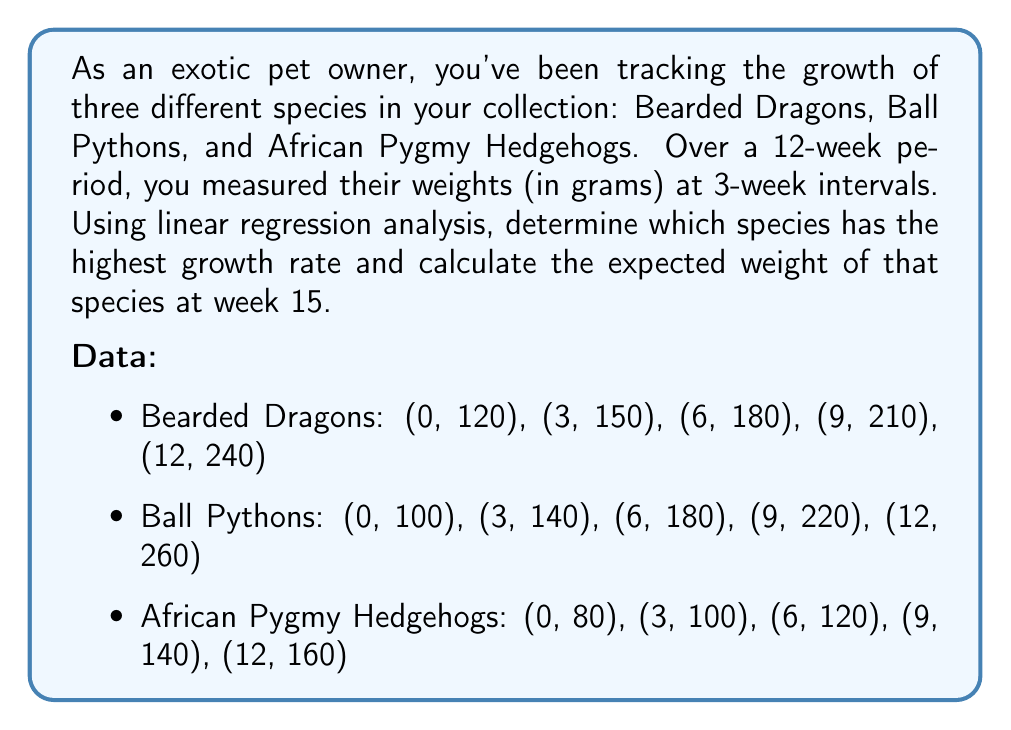Help me with this question. To solve this problem, we need to perform linear regression analysis for each species and compare their growth rates. Then, we'll use the highest growth rate to predict the weight at week 15.

Step 1: Calculate the slope (growth rate) for each species using the formula:
$$ m = \frac{n\sum xy - \sum x \sum y}{n\sum x^2 - (\sum x)^2} $$

Where $n$ is the number of data points, $x$ represents weeks, and $y$ represents weight.

For all species, we have:
$n = 5$
$\sum x = 0 + 3 + 6 + 9 + 12 = 30$
$\sum x^2 = 0^2 + 3^2 + 6^2 + 9^2 + 12^2 = 270$

Bearded Dragons:
$\sum y = 120 + 150 + 180 + 210 + 240 = 900$
$\sum xy = 0(120) + 3(150) + 6(180) + 9(210) + 12(240) = 5580$

$m_{BD} = \frac{5(5580) - 30(900)}{5(270) - 30^2} = \frac{2700}{450} = 6$ g/week

Ball Pythons:
$\sum y = 100 + 140 + 180 + 220 + 260 = 900$
$\sum xy = 0(100) + 3(140) + 6(180) + 9(220) + 12(260) = 6300$

$m_{BP} = \frac{5(6300) - 30(900)}{5(270) - 30^2} = \frac{4500}{450} = 10$ g/week

African Pygmy Hedgehogs:
$\sum y = 80 + 100 + 120 + 140 + 160 = 600$
$\sum xy = 0(80) + 3(100) + 6(120) + 9(140) + 12(160) = 3600$

$m_{APH} = \frac{5(3600) - 30(600)}{5(270) - 30^2} = \frac{1800}{450} = 4$ g/week

Step 2: Determine the species with the highest growth rate
Ball Pythons have the highest growth rate at 10 g/week.

Step 3: Calculate the expected weight of Ball Pythons at week 15
Use the point-slope form of a line: $y - y_1 = m(x - x_1)$
We can use the initial point (0, 100) and the slope 10 g/week.

$y - 100 = 10(15 - 0)$
$y - 100 = 150$
$y = 250$

Therefore, the expected weight of a Ball Python at week 15 is 250 grams.
Answer: Ball Pythons; 250 grams 